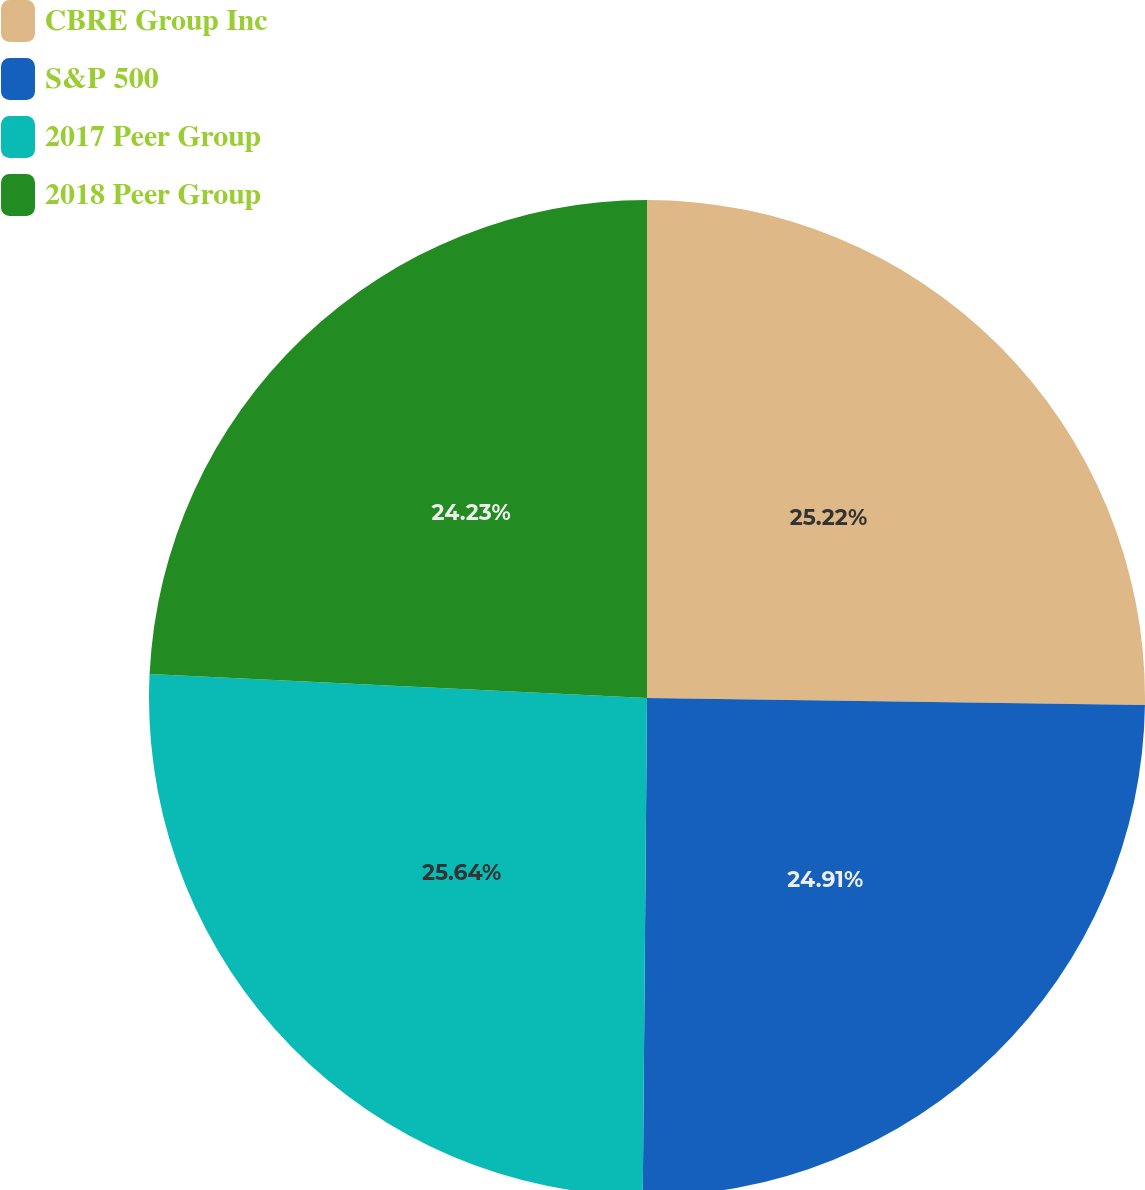Convert chart to OTSL. <chart><loc_0><loc_0><loc_500><loc_500><pie_chart><fcel>CBRE Group Inc<fcel>S&P 500<fcel>2017 Peer Group<fcel>2018 Peer Group<nl><fcel>25.22%<fcel>24.91%<fcel>25.63%<fcel>24.23%<nl></chart> 